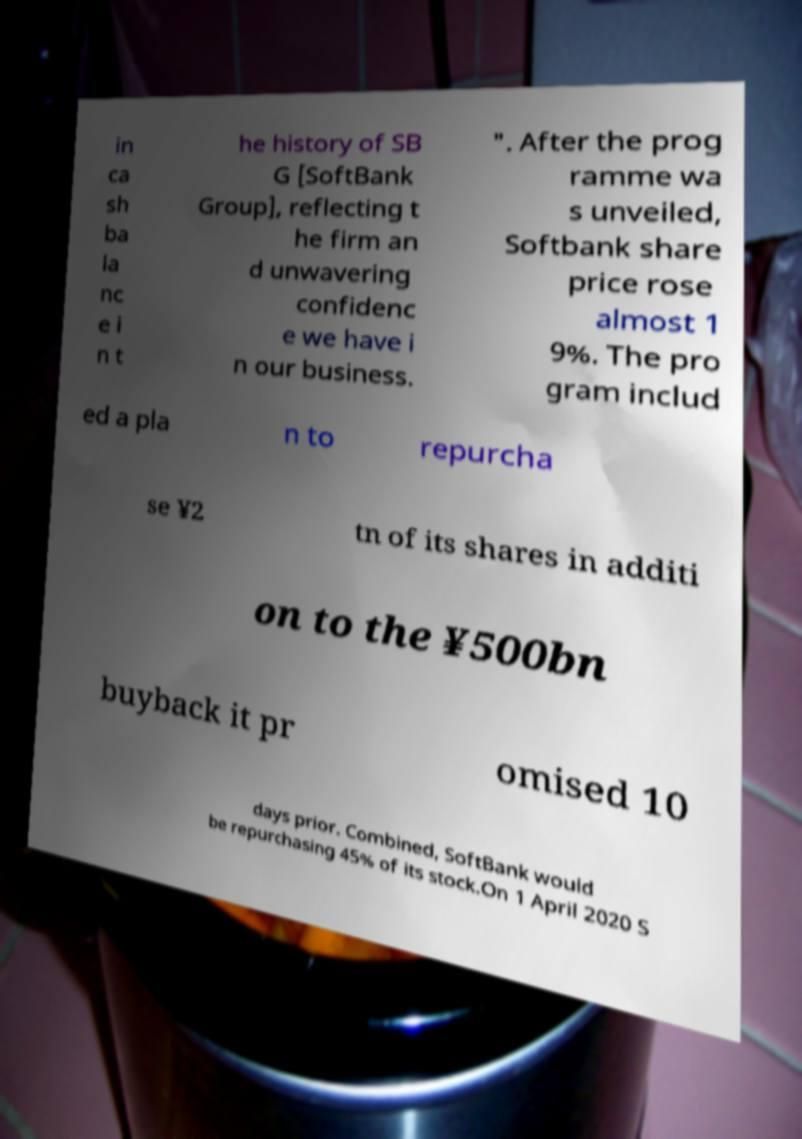I need the written content from this picture converted into text. Can you do that? in ca sh ba la nc e i n t he history of SB G [SoftBank Group], reflecting t he firm an d unwavering confidenc e we have i n our business. ". After the prog ramme wa s unveiled, Softbank share price rose almost 1 9%. The pro gram includ ed a pla n to repurcha se ¥2 tn of its shares in additi on to the ¥500bn buyback it pr omised 10 days prior. Combined, SoftBank would be repurchasing 45% of its stock.On 1 April 2020 S 